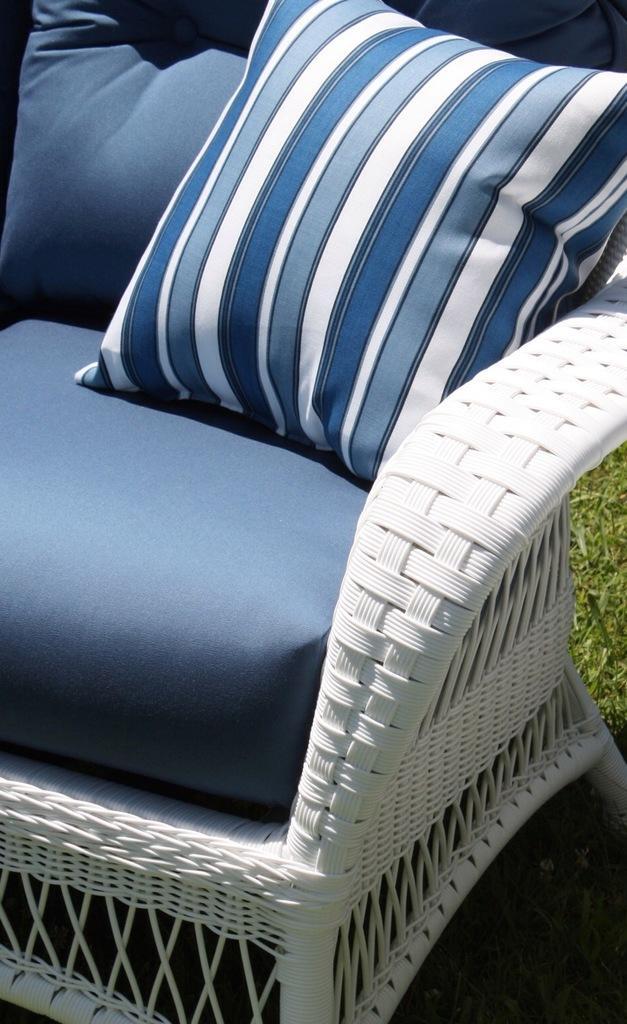How would you summarize this image in a sentence or two? There is a white sofa on the sofa there is big cushion with blue color and behind the sofa chair there is a grass 